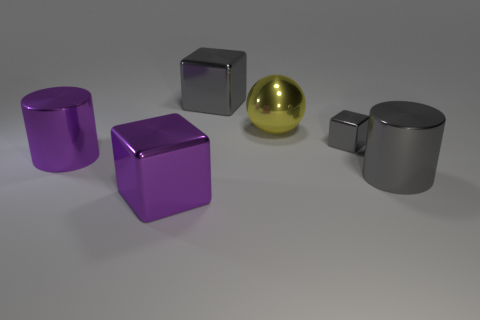How many other things are there of the same material as the large yellow sphere?
Offer a terse response. 5. What color is the large cube behind the large gray object in front of the small gray metal thing?
Provide a short and direct response. Gray. Do the large object that is behind the big yellow ball and the sphere have the same color?
Your answer should be very brief. No. Does the yellow metal ball have the same size as the purple shiny cylinder?
Make the answer very short. Yes. There is a purple thing that is the same size as the purple cylinder; what is its shape?
Offer a terse response. Cube. There is a metallic object left of the purple cube; is it the same size as the large sphere?
Provide a succinct answer. Yes. There is another cylinder that is the same size as the purple cylinder; what is its material?
Keep it short and to the point. Metal. There is a big metallic thing to the left of the big purple metallic object to the right of the purple shiny cylinder; are there any large purple blocks left of it?
Keep it short and to the point. No. Is there anything else that has the same shape as the big yellow shiny object?
Provide a succinct answer. No. Is the color of the cylinder on the left side of the purple shiny block the same as the tiny object in front of the big yellow metallic ball?
Your answer should be very brief. No. 